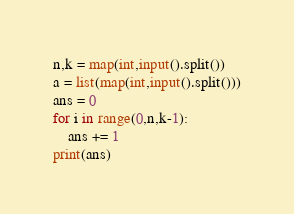Convert code to text. <code><loc_0><loc_0><loc_500><loc_500><_Python_>n,k = map(int,input().split())
a = list(map(int,input().split()))
ans = 0
for i in range(0,n,k-1):
    ans += 1
print(ans)</code> 